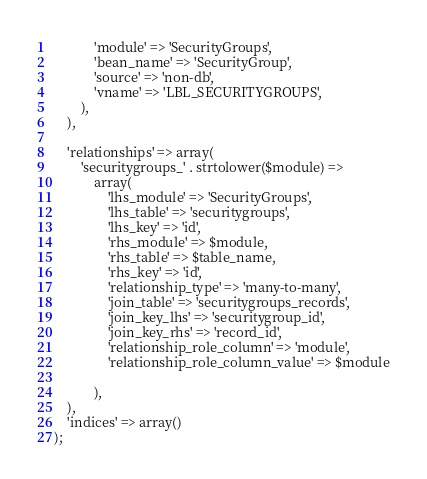Convert code to text. <code><loc_0><loc_0><loc_500><loc_500><_PHP_>            'module' => 'SecurityGroups',
            'bean_name' => 'SecurityGroup',
            'source' => 'non-db',
            'vname' => 'LBL_SECURITYGROUPS',
        ),
    ),

    'relationships' => array(
        'securitygroups_' . strtolower($module) =>
            array(
                'lhs_module' => 'SecurityGroups',
                'lhs_table' => 'securitygroups',
                'lhs_key' => 'id',
                'rhs_module' => $module,
                'rhs_table' => $table_name,
                'rhs_key' => 'id',
                'relationship_type' => 'many-to-many',
                'join_table' => 'securitygroups_records',
                'join_key_lhs' => 'securitygroup_id',
                'join_key_rhs' => 'record_id',
                'relationship_role_column' => 'module',
                'relationship_role_column_value' => $module

            ),
    ),
    'indices' => array()
);
</code> 